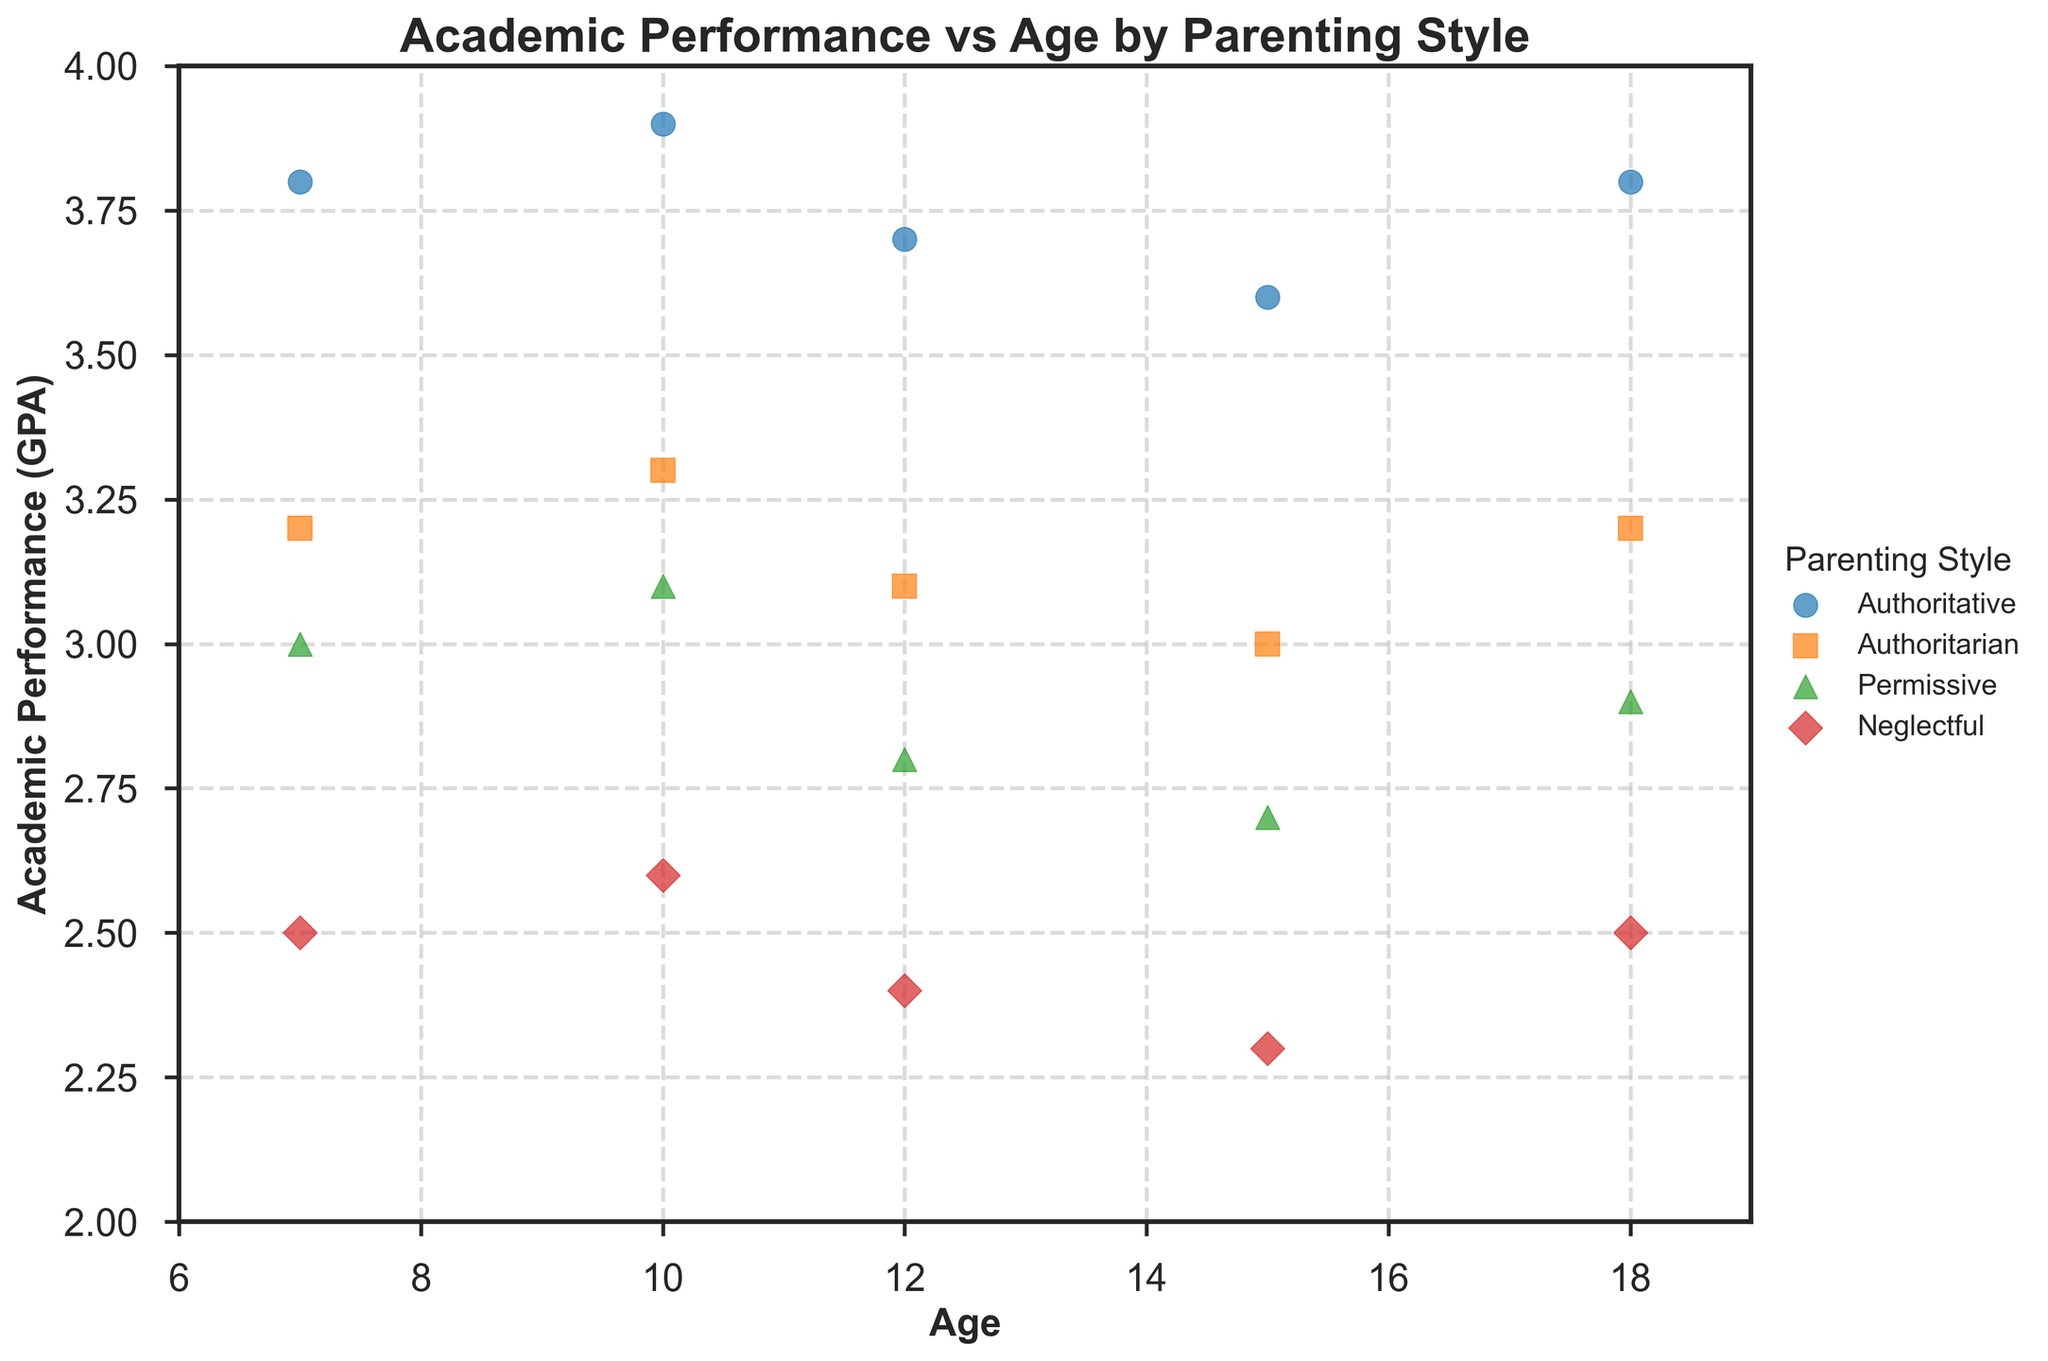What age group has the highest academic performance with an Authoritative parenting style? The highest academic performance for the Authoritative parenting style can be found by comparing the GPA values for all age groups where parenting style is Authoritative. The data shows that at age 10, the GPA is 3.9, which is the highest.
Answer: Age 10 What is the general trend in academic performance for children with a Neglectful parenting style as they age? To identify the trend, look at the academic performance (GPA) values for children with a Neglectful parenting style across different ages: 2.5 at age 7, 2.6 at age 10, 2.4 at age 12, 2.3 at age 15, and 2.5 at age 18. The general trend suggests a slight increase followed by a decrease and then a small increase again, overall showing instability.
Answer: Overall decrease with instability What's the difference in academic performance (GPA) for children aged 15 between Authoritative and Authoritarian parenting styles? The GPA for children aged 15 with Authoritative parenting style is 3.6, while for those with Authoritarian parenting style it is 3.0. The difference is calculated as 3.6 - 3.0 = 0.6.
Answer: 0.6 Which parenting style has the most significant drop in academic performance from age 10 to age 15? Check the GPAs for each parenting style at ages 10 and 15. Calculate the drops:
- Authoritative: 3.9 to 3.6 => 0.3
- Authoritarian: 3.3 to 3.0 => 0.3
- Permissive: 3.1 to 2.7 => 0.4
- Neglectful: 2.6 to 2.3 => 0.3
The Permissive style has the most significant drop (0.4 points).
Answer: Permissive Which parenting style consistently shows higher academic performance (GPA) across all ages? Compare the plotted GPA values for all parenting styles across all ages. The Authoritative parenting style consistently shows the highest GPA values compared to the other styles at each age level.
Answer: Authoritative Are there any ages where the academic performance for children with Permissive parenting style is higher than those with Authoritarian style? Compare the GPA values for Permissive and Authoritarian styles at each age. At no age does the Permissive style outperform the Authoritarian style; the GPA is always lower for Permissive compared to Authoritarian.
Answer: No What is the average academic performance (GPA) for children aged 12? Locate the GPA values for age 12 under each parenting style and calculate the average: (3.7 + 3.1 + 2.8 + 2.4) / 4 equals 3.0.
Answer: 3.0 How does the academic performance of children with Authoritarian parenting style change from age 7 to age 18? Note the GPAs for Authoritarian style at ages 7, 10, 12, 15, and 18: 3.2, 3.3, 3.1, 3.0, and 3.2. The performance starts at 3.2, slightly increases to 3.3 at age 10, then decreases to 3.1 and 3.0 before returning to 3.2 at age 18, indicating fluctuation but remaining relatively stable around 3.2.
Answer: Fluctuating around 3.2 